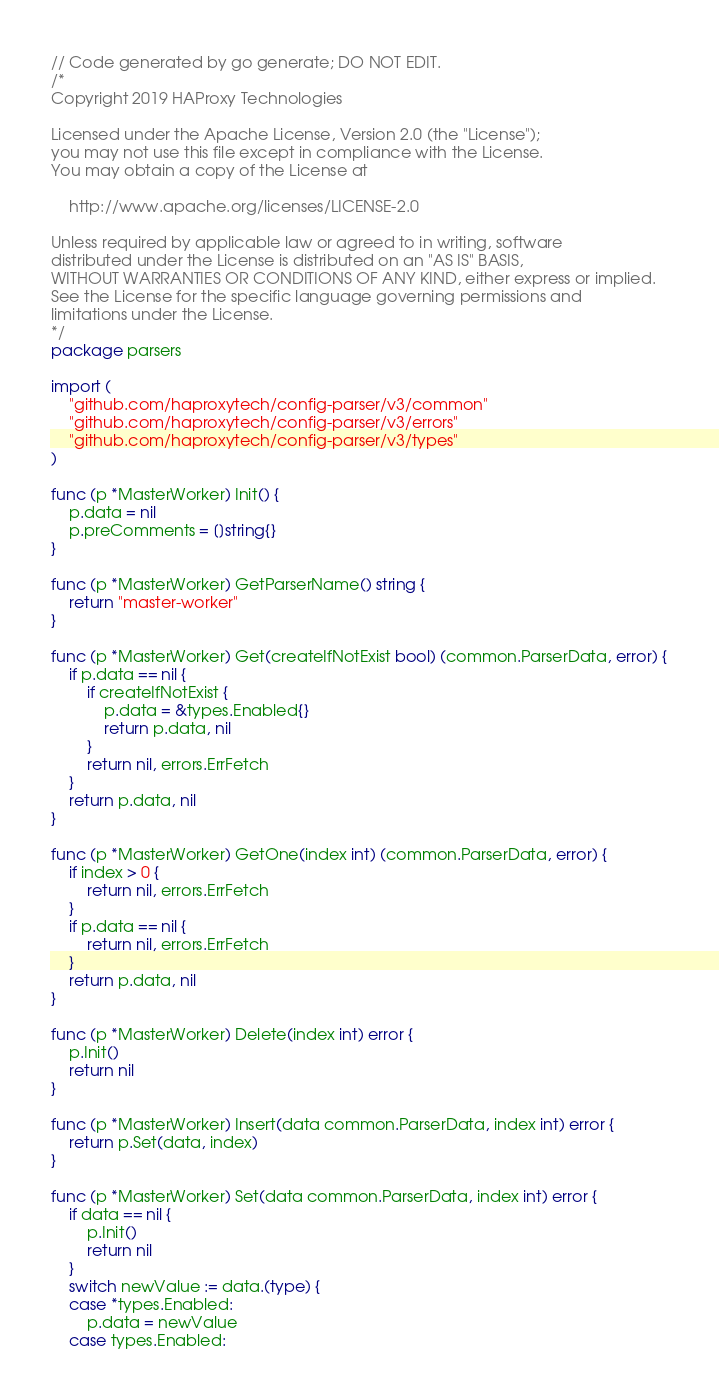<code> <loc_0><loc_0><loc_500><loc_500><_Go_>// Code generated by go generate; DO NOT EDIT.
/*
Copyright 2019 HAProxy Technologies

Licensed under the Apache License, Version 2.0 (the "License");
you may not use this file except in compliance with the License.
You may obtain a copy of the License at

    http://www.apache.org/licenses/LICENSE-2.0

Unless required by applicable law or agreed to in writing, software
distributed under the License is distributed on an "AS IS" BASIS,
WITHOUT WARRANTIES OR CONDITIONS OF ANY KIND, either express or implied.
See the License for the specific language governing permissions and
limitations under the License.
*/
package parsers

import (
	"github.com/haproxytech/config-parser/v3/common"
	"github.com/haproxytech/config-parser/v3/errors"
	"github.com/haproxytech/config-parser/v3/types"
)

func (p *MasterWorker) Init() {
    p.data = nil
    p.preComments = []string{}
}

func (p *MasterWorker) GetParserName() string {
	return "master-worker"
}

func (p *MasterWorker) Get(createIfNotExist bool) (common.ParserData, error) {
	if p.data == nil {
		if createIfNotExist {
			p.data = &types.Enabled{}
			return p.data, nil
		}
		return nil, errors.ErrFetch
	}
	return p.data, nil
}

func (p *MasterWorker) GetOne(index int) (common.ParserData, error) {
	if index > 0 {
		return nil, errors.ErrFetch
	}
	if p.data == nil {
		return nil, errors.ErrFetch
	}
	return p.data, nil
}

func (p *MasterWorker) Delete(index int) error {
	p.Init()
	return nil
}

func (p *MasterWorker) Insert(data common.ParserData, index int) error {
	return p.Set(data, index)
}

func (p *MasterWorker) Set(data common.ParserData, index int) error {
	if data == nil {
		p.Init()
		return nil
	}
	switch newValue := data.(type) {
	case *types.Enabled:
		p.data = newValue
	case types.Enabled:</code> 